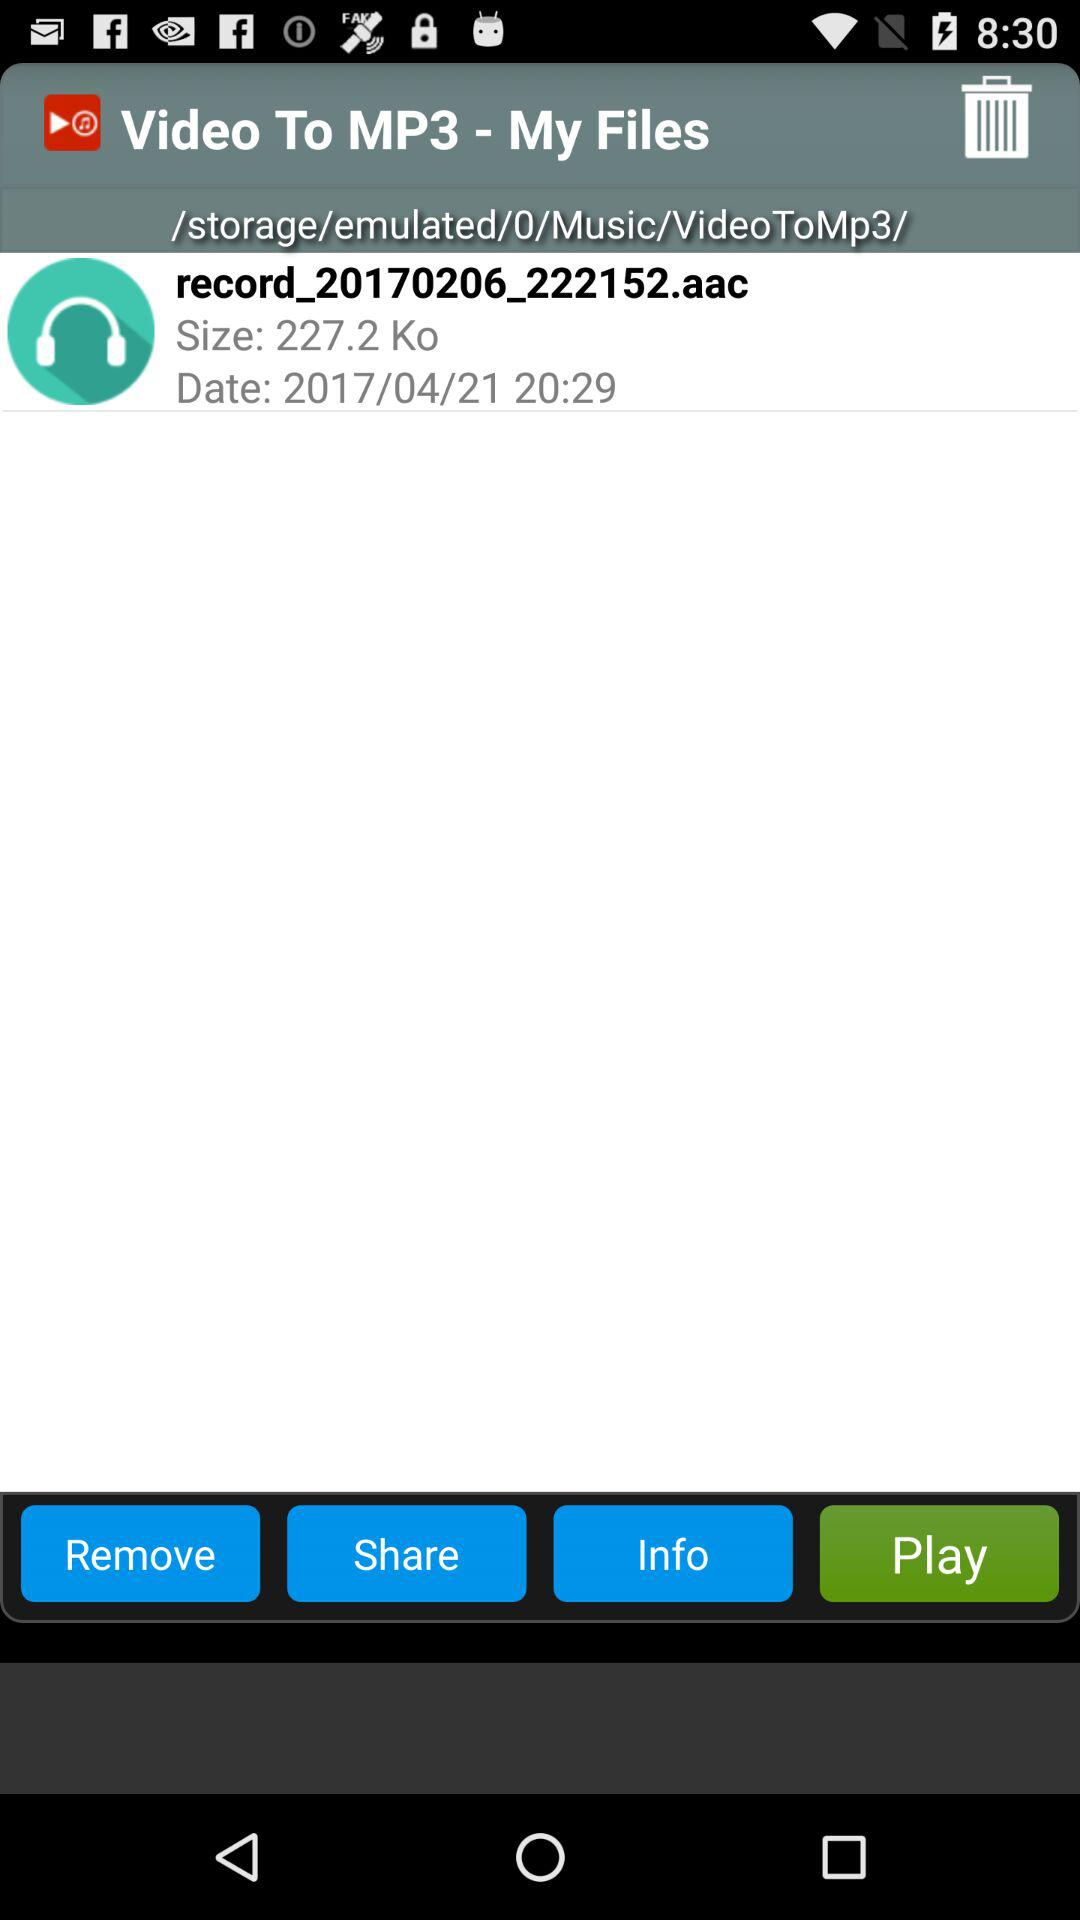What is the application name? The application name is "Video to mp3". 